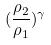<formula> <loc_0><loc_0><loc_500><loc_500>( \frac { \rho _ { 2 } } { \rho _ { 1 } } ) ^ { \gamma }</formula> 